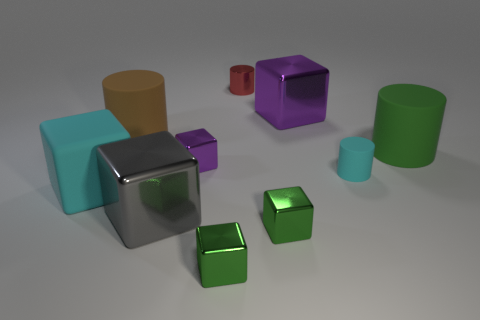Subtract all brown cylinders. How many cylinders are left? 3 Subtract all gray cylinders. How many green blocks are left? 2 Subtract all cyan cylinders. How many cylinders are left? 3 Subtract all blocks. How many objects are left? 4 Subtract 2 cylinders. How many cylinders are left? 2 Subtract all green cylinders. Subtract all red spheres. How many cylinders are left? 3 Add 2 big shiny blocks. How many big shiny blocks are left? 4 Add 5 large red metallic balls. How many large red metallic balls exist? 5 Subtract 0 purple balls. How many objects are left? 10 Subtract all red metallic cylinders. Subtract all tiny shiny cubes. How many objects are left? 6 